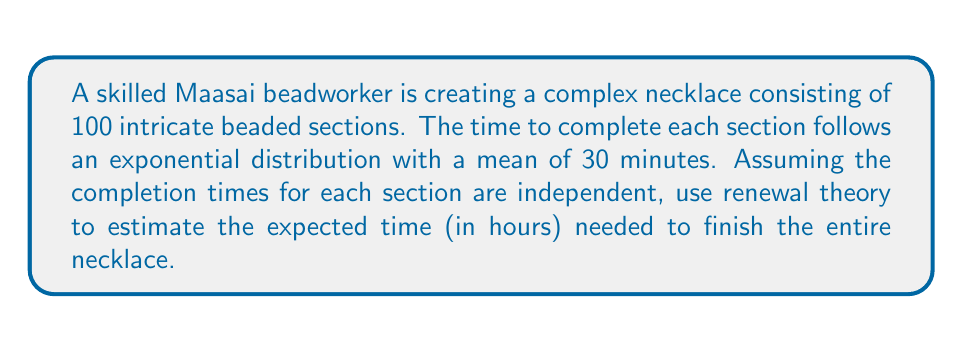Solve this math problem. Let's approach this problem using renewal theory:

1) In renewal theory, we consider a sequence of independent and identically distributed (i.i.d.) random variables. Here, each beaded section's completion time is an i.i.d. random variable.

2) The exponential distribution has the memoryless property, which makes it suitable for renewal processes.

3) Given:
   - Number of sections: $n = 100$
   - Mean time per section: $\mathbb{E}[X] = 30$ minutes

4) In renewal theory, the expected time for $n$ renewals is given by:

   $$\mathbb{E}[T_n] = n \cdot \mathbb{E}[X]$$

   where $T_n$ is the time for $n$ renewals and $X$ is the time between renewals.

5) Substituting our values:

   $$\mathbb{E}[T_{100}] = 100 \cdot 30 = 3000 \text{ minutes}$$

6) Convert minutes to hours:

   $$3000 \text{ minutes} \cdot \frac{1 \text{ hour}}{60 \text{ minutes}} = 50 \text{ hours}$$

Therefore, the expected time to complete the necklace is 50 hours.
Answer: 50 hours 